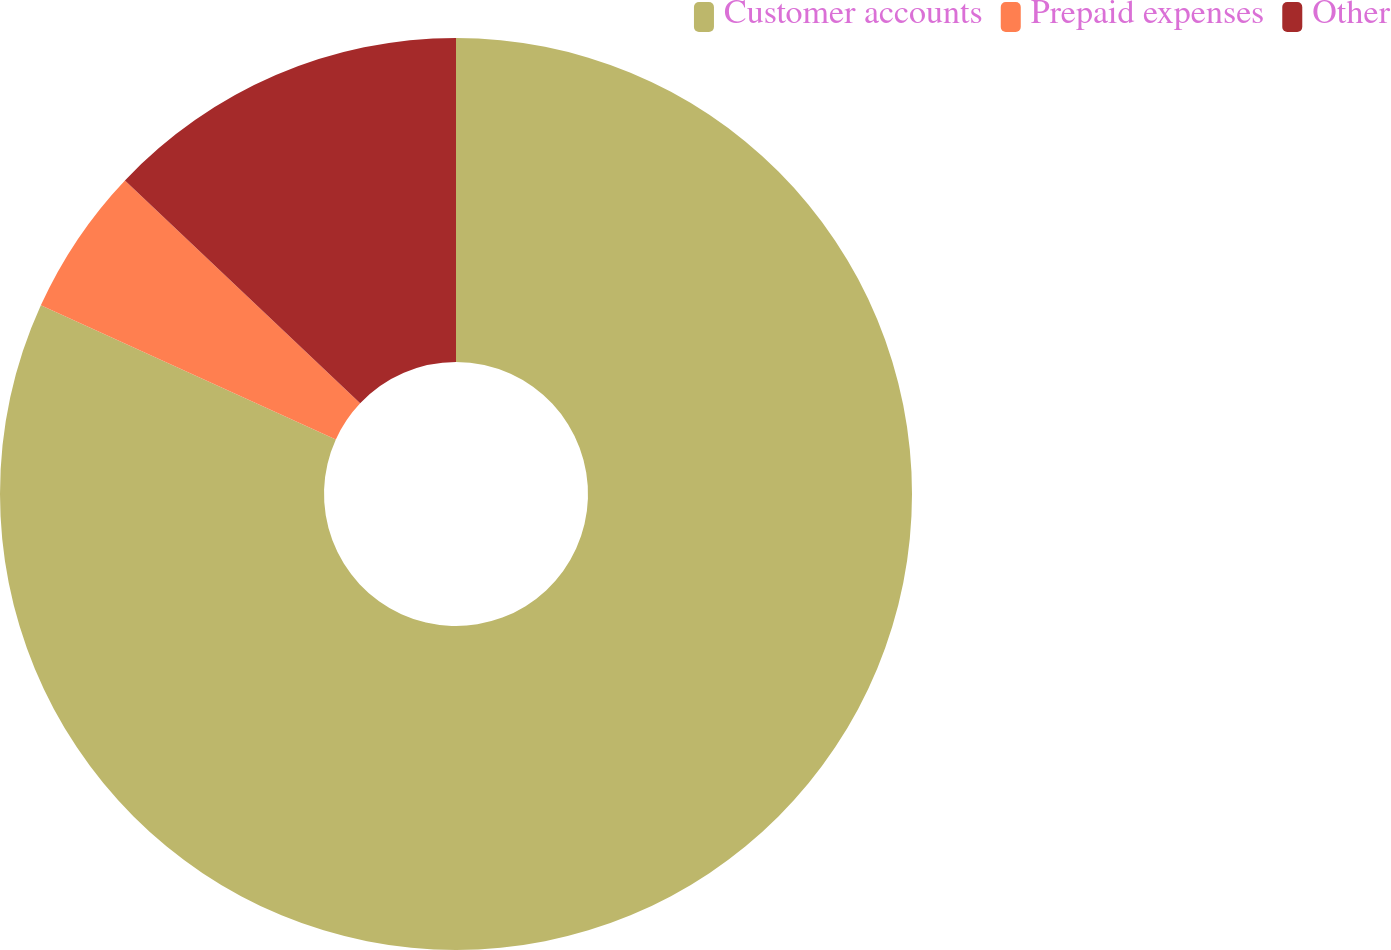<chart> <loc_0><loc_0><loc_500><loc_500><pie_chart><fcel>Customer accounts<fcel>Prepaid expenses<fcel>Other<nl><fcel>81.78%<fcel>5.28%<fcel>12.93%<nl></chart> 